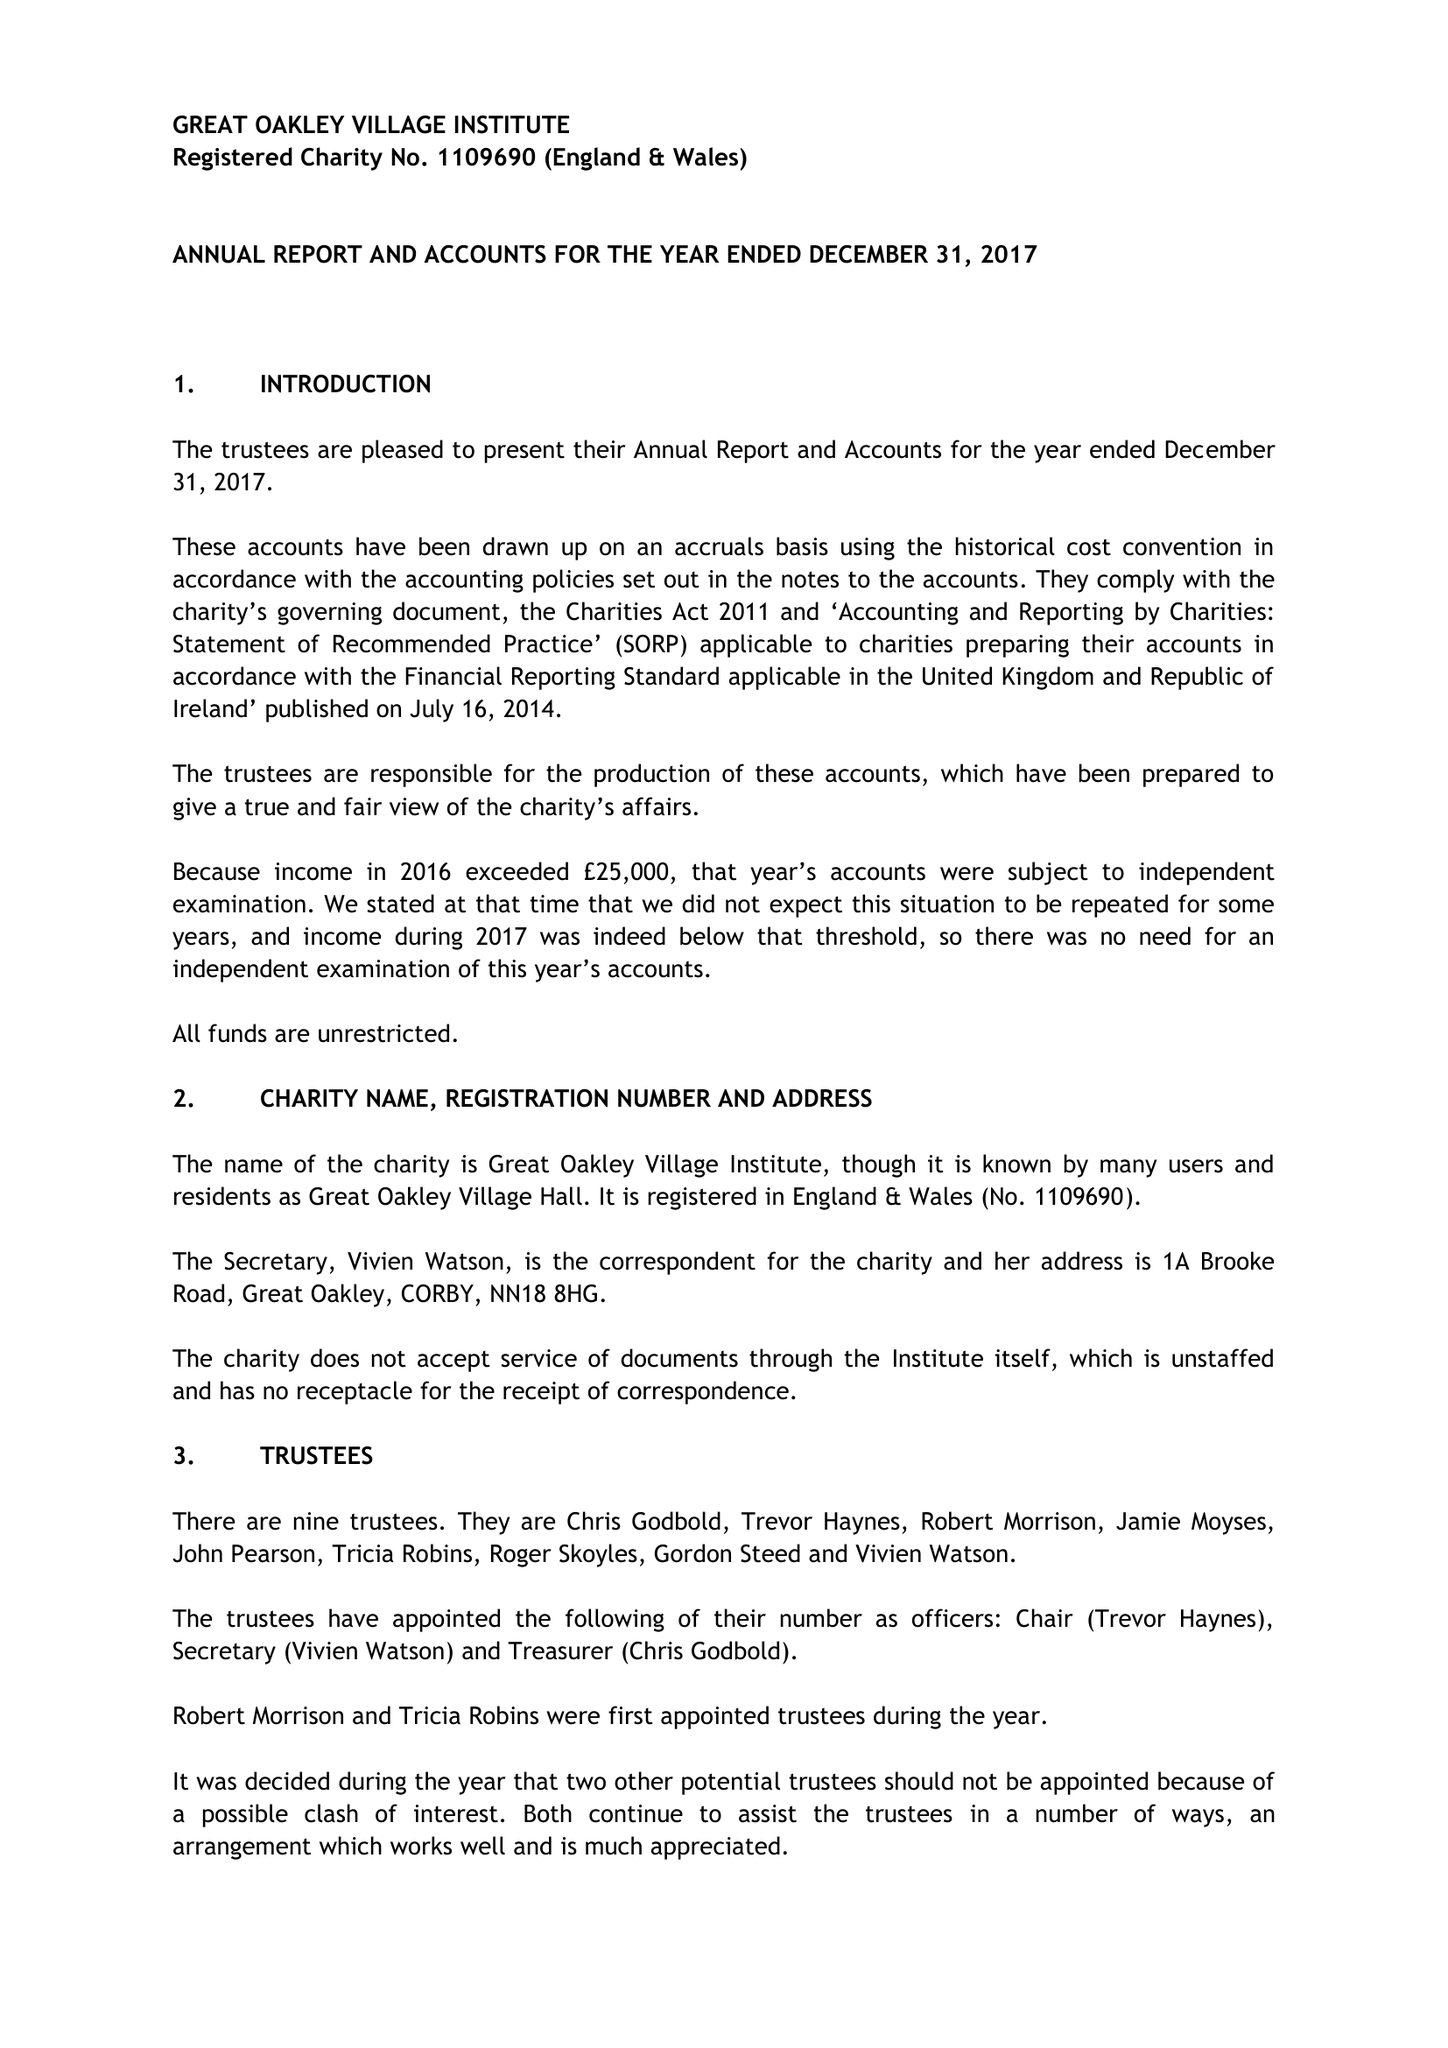What is the value for the address__postcode?
Answer the question using a single word or phrase. NN18 8HG 